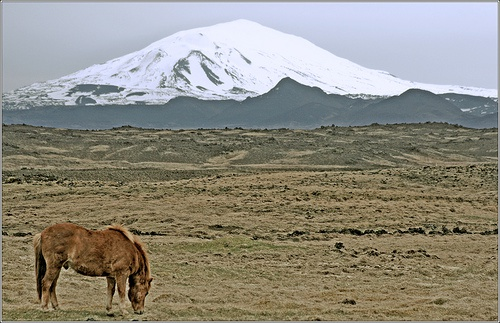Describe the objects in this image and their specific colors. I can see a horse in black, maroon, and gray tones in this image. 